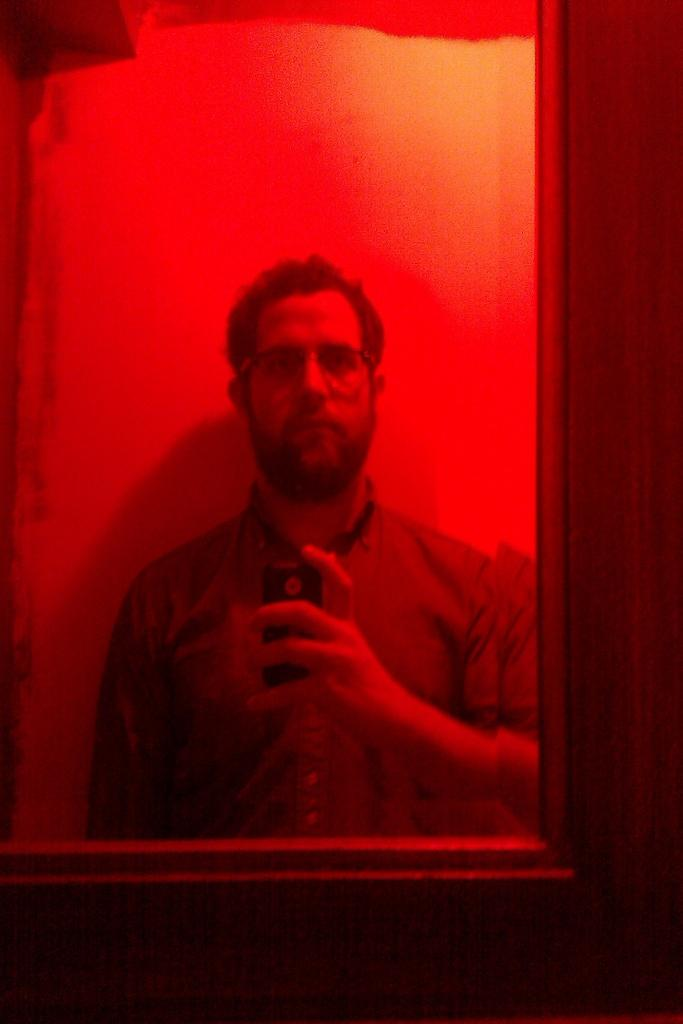What is the person in the image holding? The person is holding a mobile in the image. Can you describe the person's surroundings? The person's reflection is visible on a mirror in the image. What is the mirror attached to? The mirror is attached to a wooden object. How many dinosaurs are visible in the image? There are no dinosaurs present in the image. 